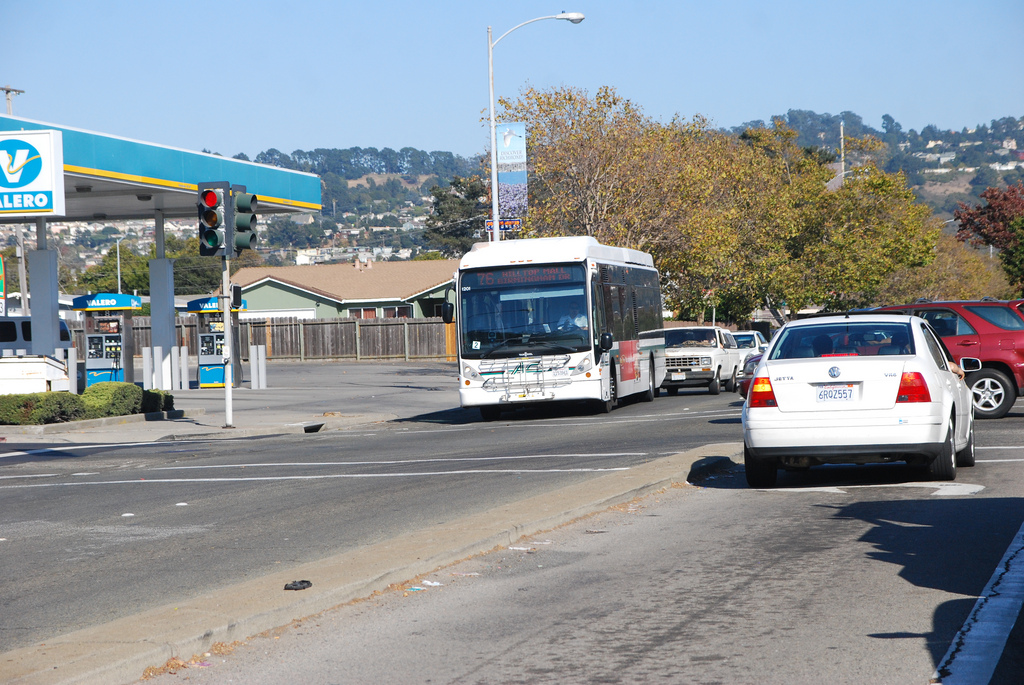What type of vehicle is on the road? There is a white car on the road, driving in the same direction as a bus further ahead. 